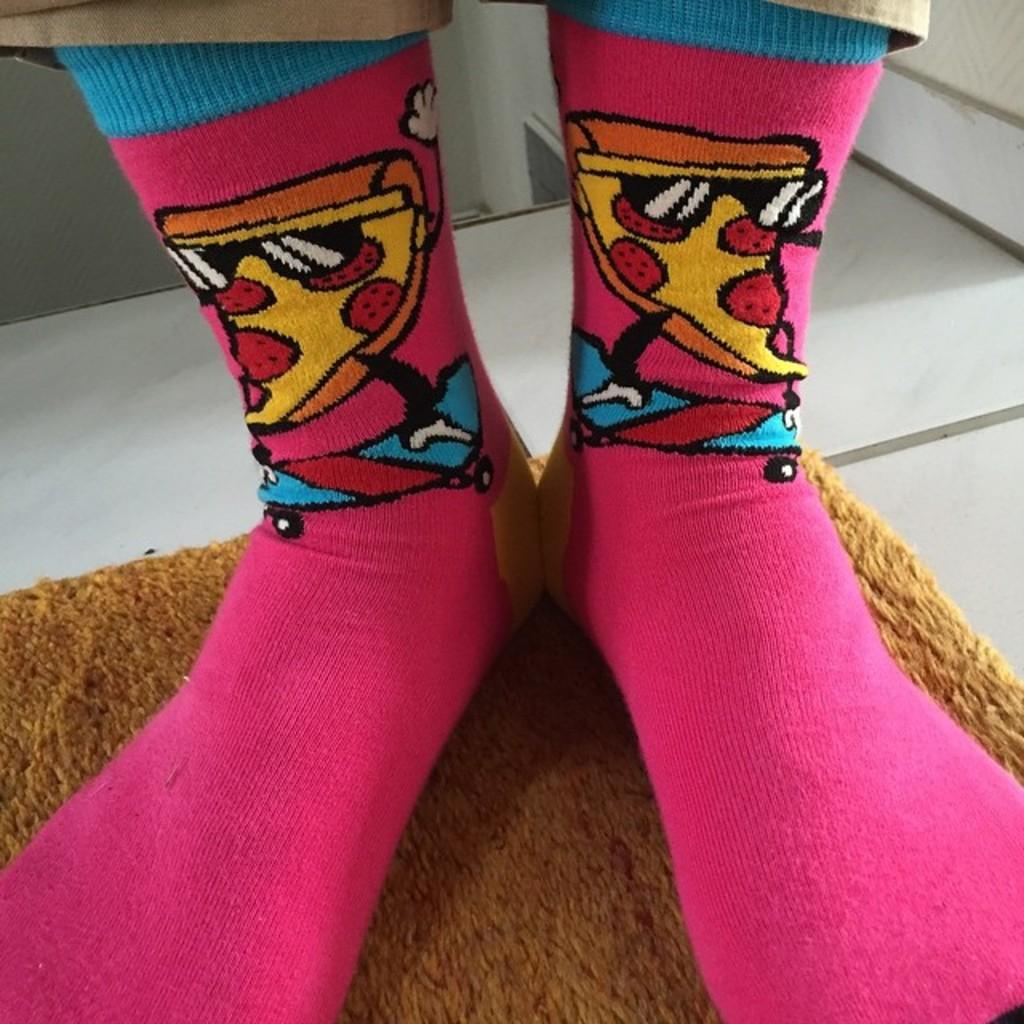What body part can be seen in the image? Legs with socks are visible in the image. What is located on the floor in the image? There is a doormat in the image. Where is the doormat placed in the image? The doormat is on the floor. What type of river can be seen flowing through the image? There is no river present in the image; it only features legs with socks and a doormat. 